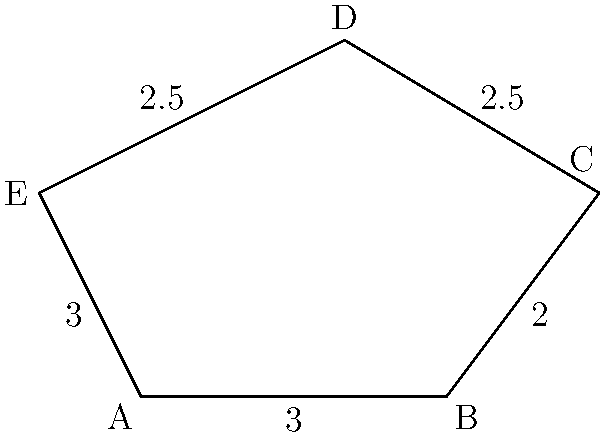A novel drug molecule has a pentagonal structure as shown above. The side lengths (in Angstroms) are given in the diagram. Calculate the perimeter of this molecular structure and express your answer in nanometers (nm). To solve this problem, we'll follow these steps:

1. Sum up all the side lengths:
   $3 + 2 + 2.5 + 2.5 + 3 = 13$ Angstroms

2. Convert the result from Angstroms to nanometers:
   1 Angstrom = 0.1 nm
   
   $13 \text{ Å} \times \frac{0.1 \text{ nm}}{1 \text{ Å}} = 1.3 \text{ nm}$

Therefore, the perimeter of the pentagonal molecular structure is 1.3 nm.
Answer: 1.3 nm 